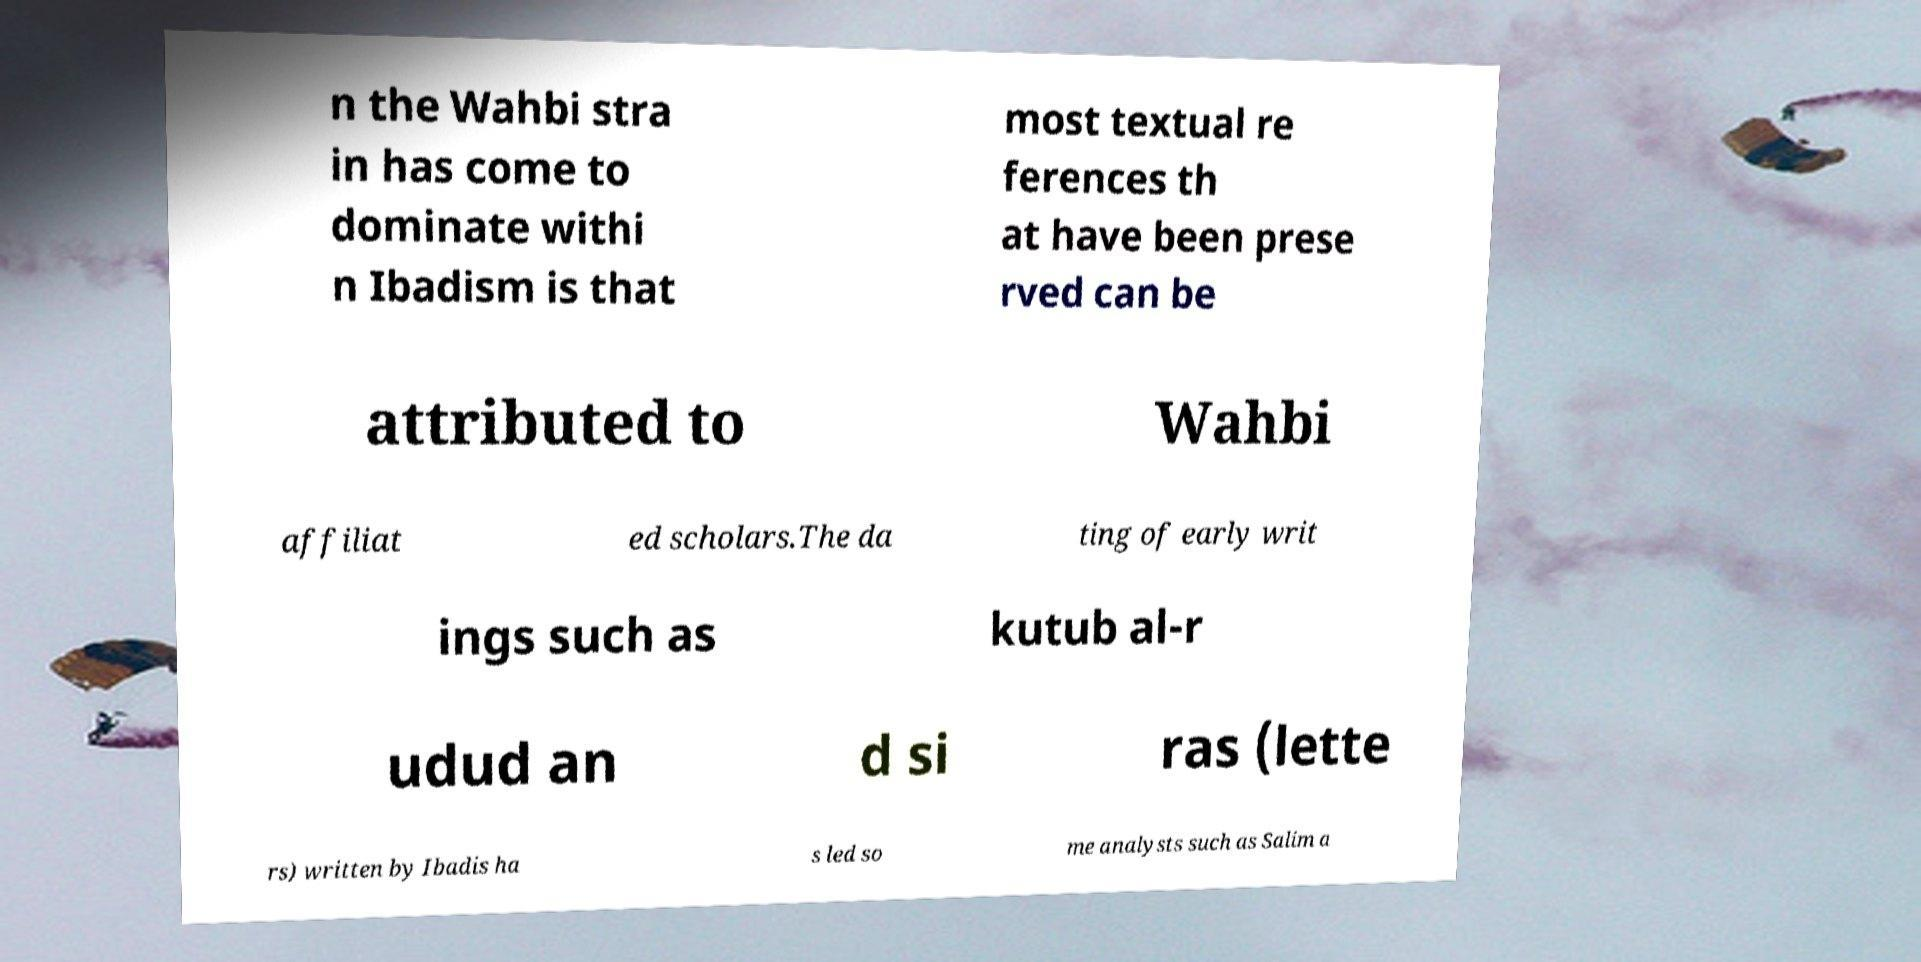Please read and relay the text visible in this image. What does it say? n the Wahbi stra in has come to dominate withi n Ibadism is that most textual re ferences th at have been prese rved can be attributed to Wahbi affiliat ed scholars.The da ting of early writ ings such as kutub al-r udud an d si ras (lette rs) written by Ibadis ha s led so me analysts such as Salim a 